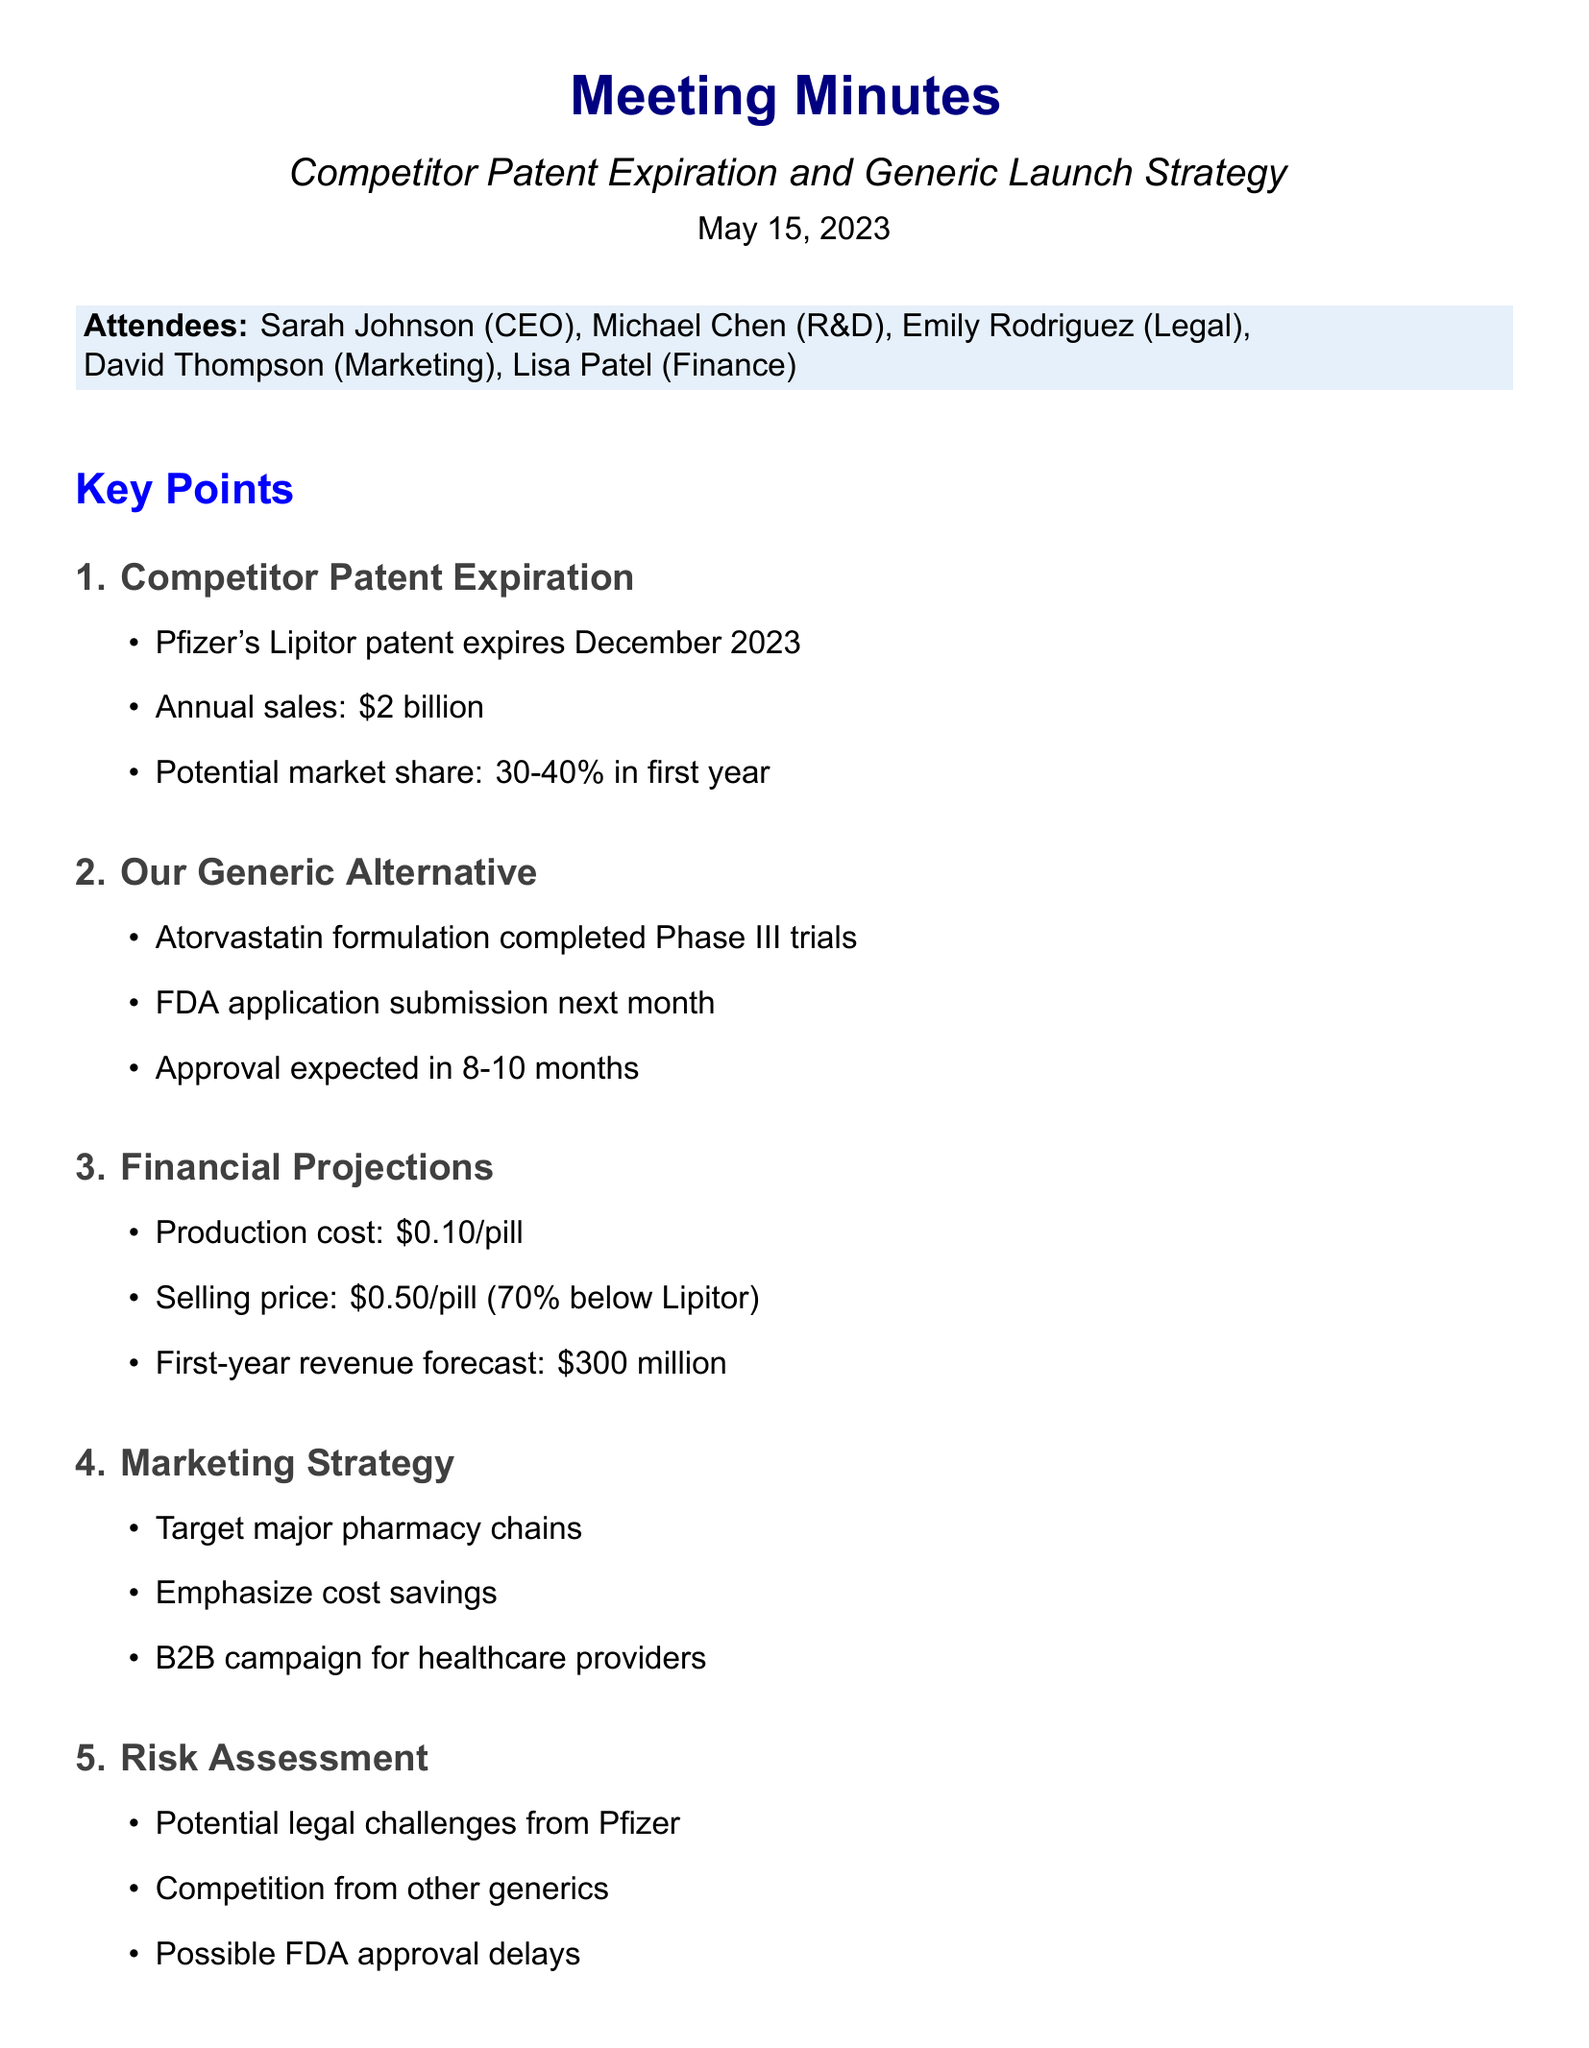what is the title of the meeting? The title of the meeting is stated at the beginning of the document.
Answer: Competitor Patent Expiration and Generic Launch Strategy who are the attendees of the meeting? The attendees are listed in the document.
Answer: Sarah Johnson, Michael Chen, Emily Rodriguez, David Thompson, Lisa Patel when does Pfizer's Lipitor patent expire? The expiration date is mentioned under the Competitor Patent Expiration section.
Answer: December 2023 what is the estimated annual sales of Lipitor? The estimated annual sales for Lipitor are provided in the details.
Answer: $2 billion what is the projected approval timeline for the generic alternative? The projected approval timeline is specified in the Generic Alternative Development Progress section.
Answer: 8-10 months what is the production cost per pill for the generic? The production cost is outlined in the Financial Projections section.
Answer: $0.10 per pill what is the first-year revenue forecast for the generic? The first-year revenue forecast is provided in the Financial Projections section.
Answer: $300 million what strategy is emphasized to target pharmacy chains? The marketing strategy emphasizes a specific aspect to attract pharmacy chains.
Answer: Cost savings what are the next steps regarding the FDA application? The next steps related to the FDA application are detailed at the end of the document.
Answer: Finalize FDA application by June 1, 2023 